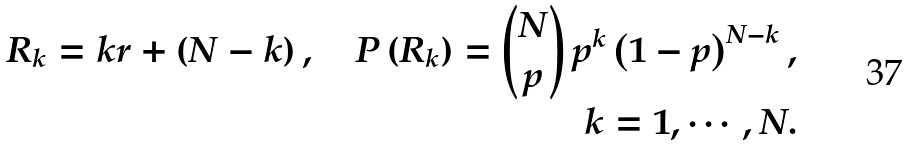Convert formula to latex. <formula><loc_0><loc_0><loc_500><loc_500>R _ { k } = k r + \left ( N - k \right ) , \quad P \left ( R _ { k } \right ) = \binom { N } { p } \, p ^ { k } \left ( 1 - p \right ) ^ { N - k } , \\ \quad k = 1 , \cdots , N .</formula> 